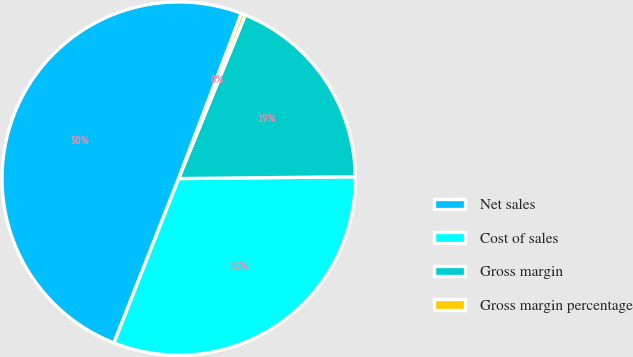Convert chart to OTSL. <chart><loc_0><loc_0><loc_500><loc_500><pie_chart><fcel>Net sales<fcel>Cost of sales<fcel>Gross margin<fcel>Gross margin percentage<nl><fcel>49.8%<fcel>31.13%<fcel>18.67%<fcel>0.39%<nl></chart> 